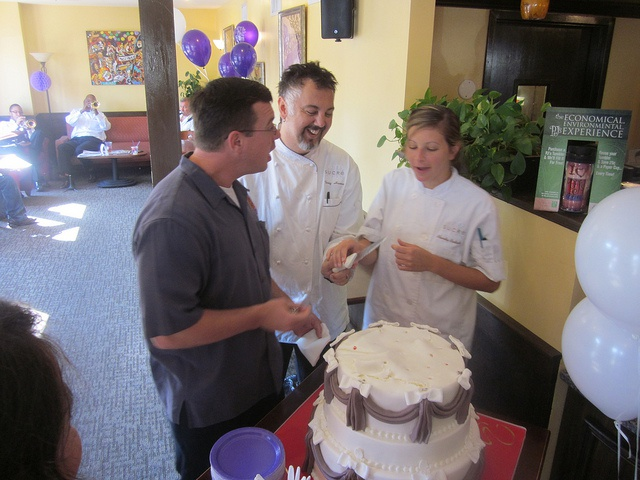Describe the objects in this image and their specific colors. I can see people in ivory, black, gray, and brown tones, people in ivory, darkgray, gray, and brown tones, cake in ivory, darkgray, tan, gray, and lightgray tones, people in ivory, darkgray, gray, and lightgray tones, and people in ivory, black, maroon, and gray tones in this image. 